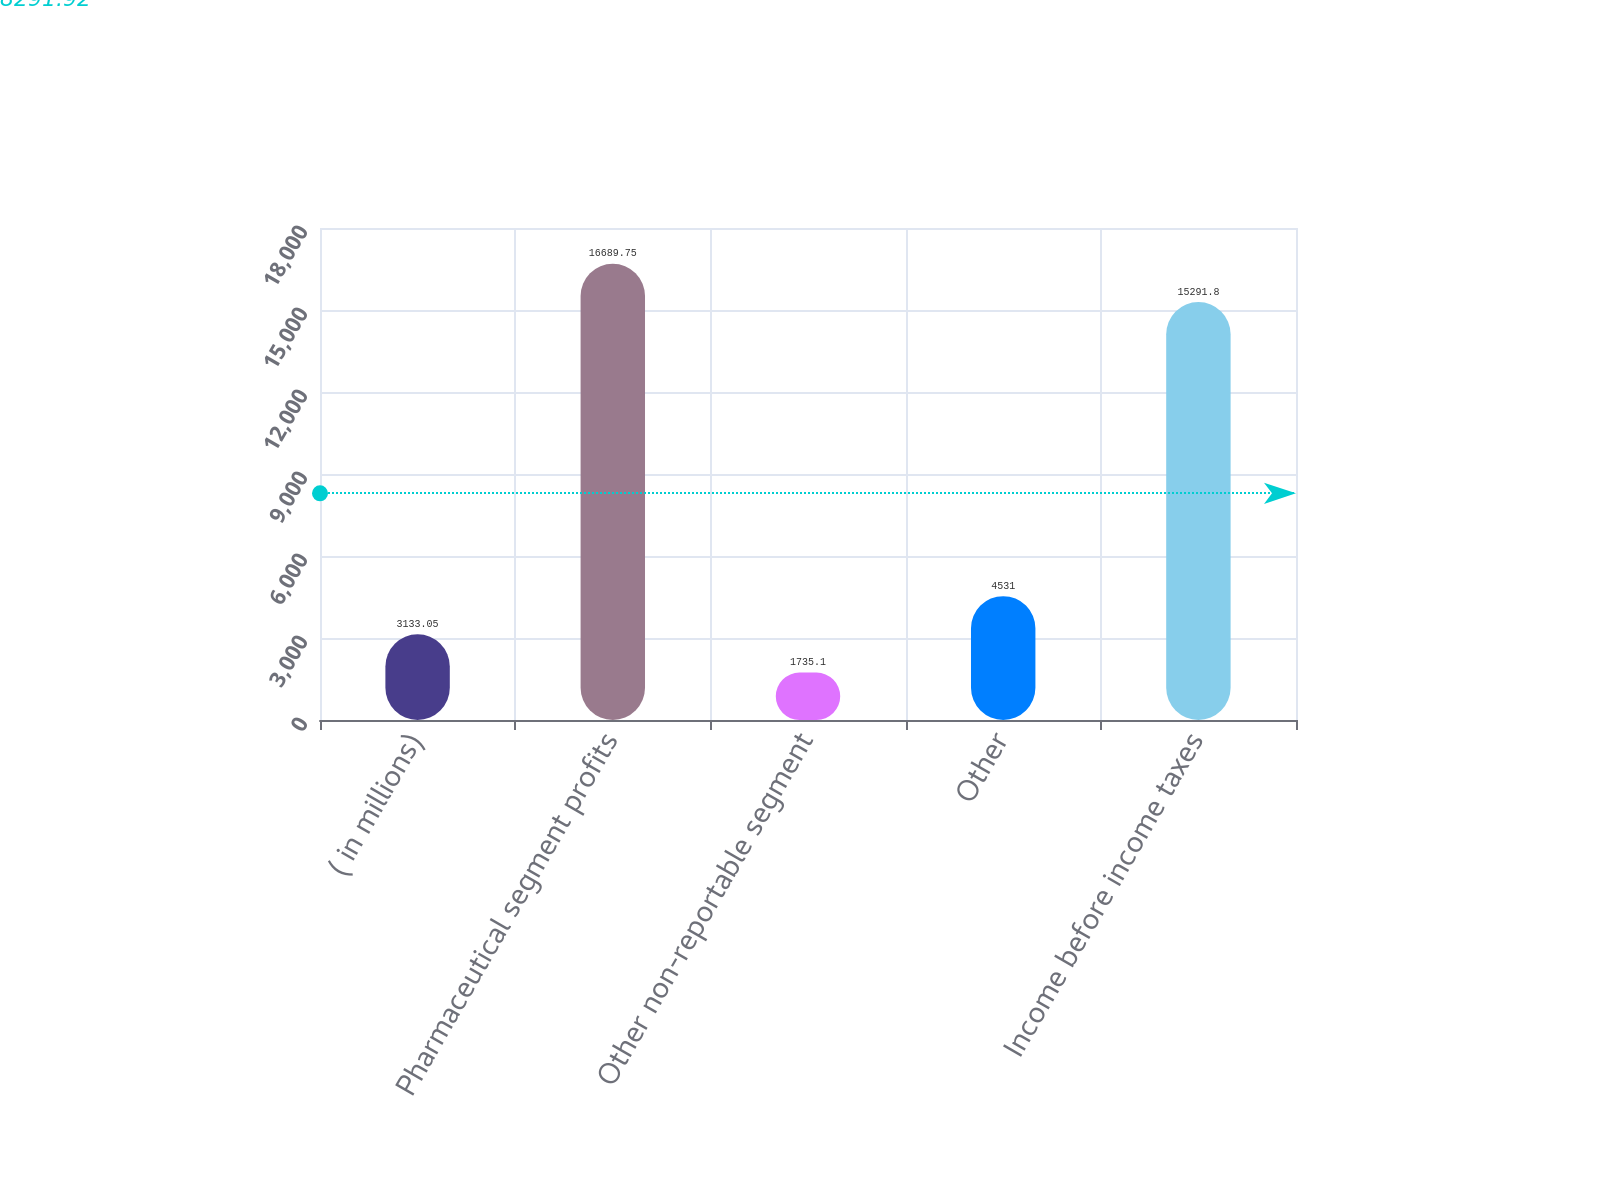<chart> <loc_0><loc_0><loc_500><loc_500><bar_chart><fcel>( in millions)<fcel>Pharmaceutical segment profits<fcel>Other non-reportable segment<fcel>Other<fcel>Income before income taxes<nl><fcel>3133.05<fcel>16689.8<fcel>1735.1<fcel>4531<fcel>15291.8<nl></chart> 